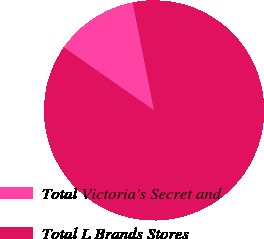Convert chart. <chart><loc_0><loc_0><loc_500><loc_500><pie_chart><fcel>Total Victoria's Secret and<fcel>Total L Brands Stores<nl><fcel>12.2%<fcel>87.8%<nl></chart> 